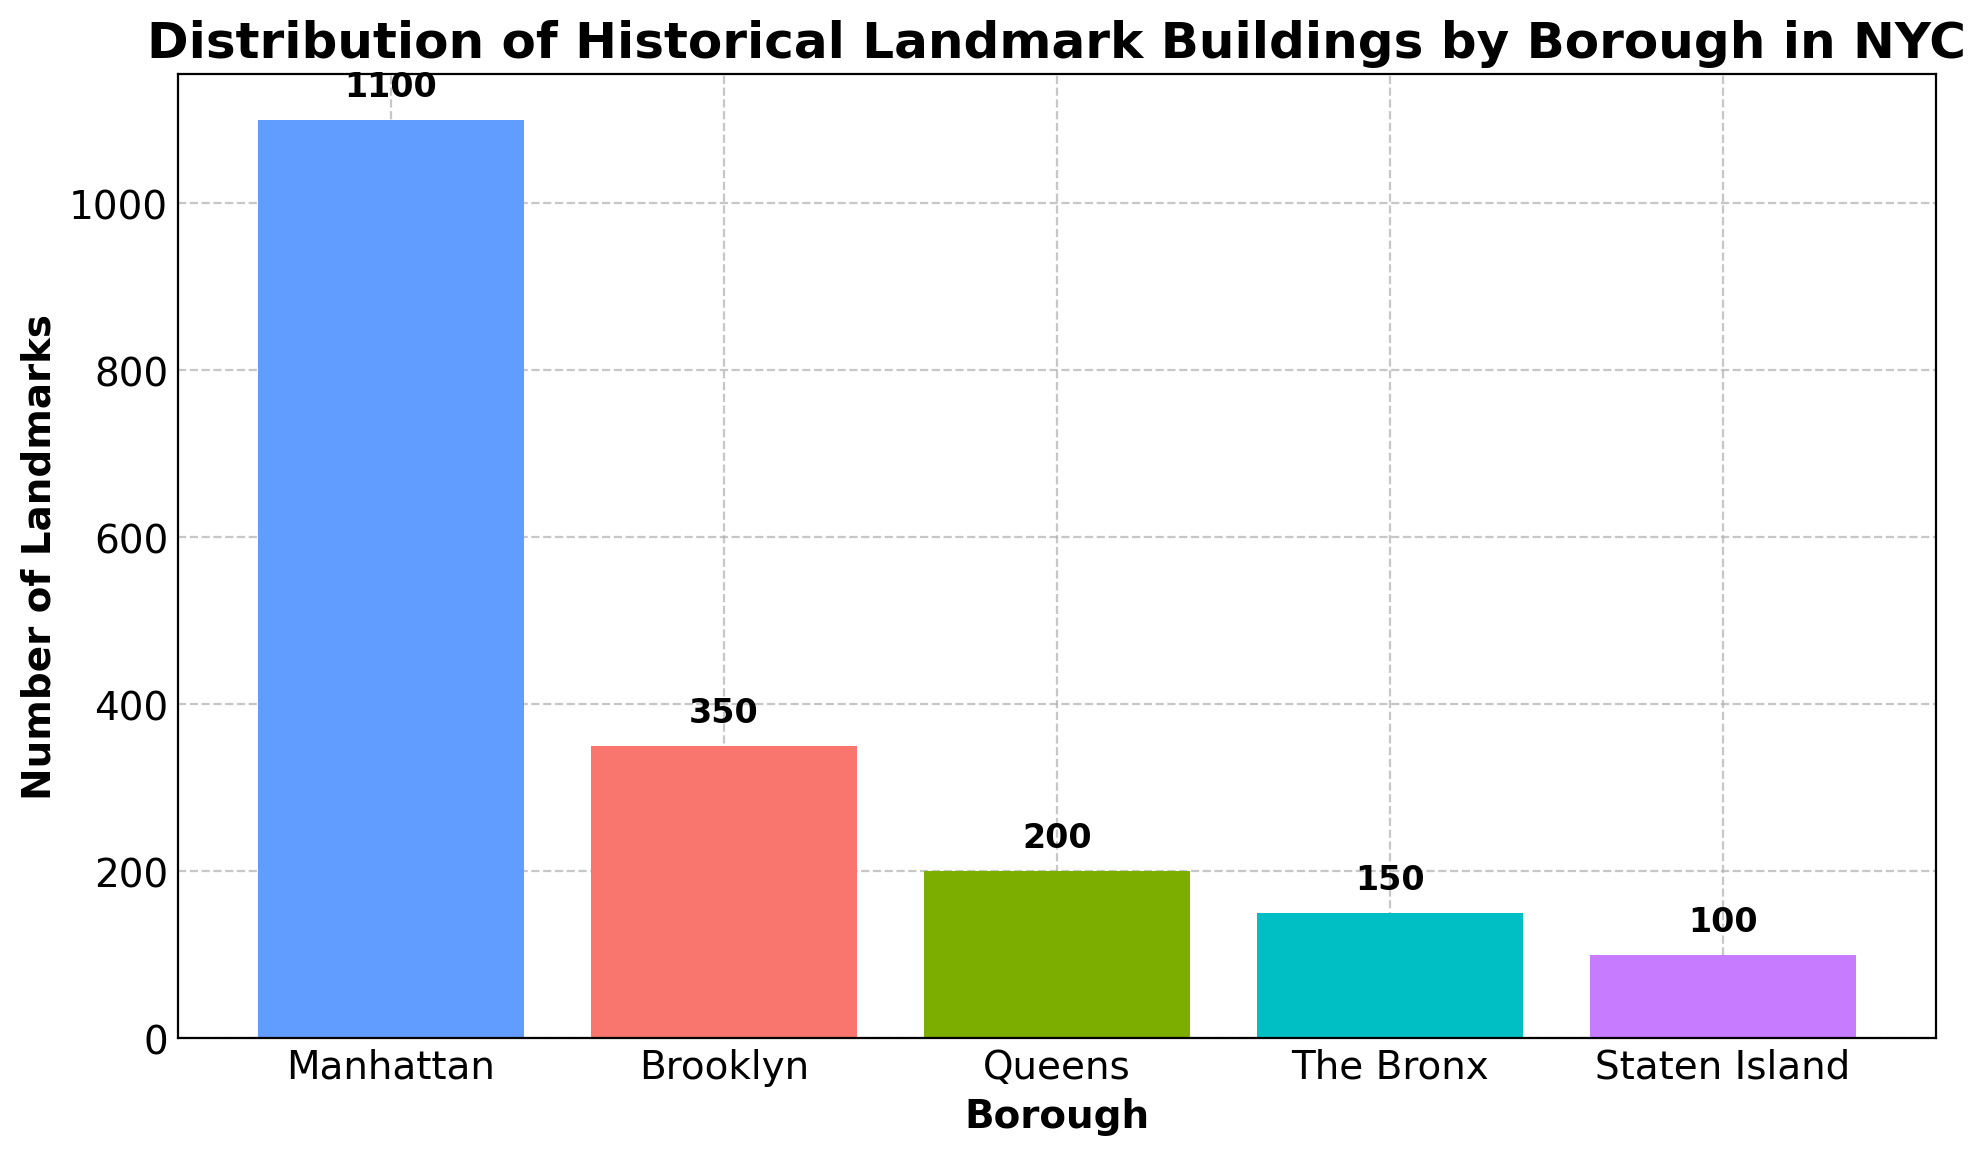What is the total number of historical landmark buildings in all five boroughs? Sum the number of landmarks from each borough: 1100 (Manhattan) + 350 (Brooklyn) + 200 (Queens) + 150 (The Bronx) + 100 (Staten Island) = 1900
Answer: 1900 Which borough has the highest number of historical landmarks? Compare the number of landmarks in each borough: Manhattan (1100) has the highest.
Answer: Manhattan How much greater is the number of landmarks in Manhattan compared to Staten Island? Subtract the number of landmarks in Staten Island from Manhattan: 1100 - 100 = 1000
Answer: 1000 What is the average number of landmarks per borough? Divide the total number of landmarks by the number of boroughs: 1900 / 5 = 380
Answer: 380 Which borough has the second lowest number of historical landmarks? Order the boroughs by the number of landmarks: Staten Island (100) < The Bronx (150) < Queens (200) < Brooklyn (350) < Manhattan (1100); The Bronx is second lowest.
Answer: The Bronx Are there more landmarks in Brooklyn and Queens combined than in Manhattan alone? Sum the landmarks in Brooklyn and Queens: 350 + 200 = 550; Compare with Manhattan: 550 < 1100, so no.
Answer: No By how much is the number of landmarks in Brooklyn less than the total number of landmarks in Queens and The Bronx combined? Calculate the total landmarks in Queens and The Bronx: 200 + 150 = 350; Subtract Brooklyn's landmarks from the combined total: 350 - 350 = 0
Answer: 0 What is the proportional increase in the number of landmarks from Staten Island to Queens? Calculate: (Queens' landmarks - Staten Island's landmarks) / Staten Island's landmarks = (200 - 100) / 100 = 1 or 100%.
Answer: 100% If Manhattan's landmarks were reduced by 10%, how many landmarks would remain? Calculate 10% of Manhattan's landmarks: 1100 * 0.10 = 110; Subtract from the original: 1100 - 110 = 990
Answer: 990 Which two boroughs combined nearly equal the number of landmarks in Manhattan? Summing the landmarks of different pairs: (Brooklyn + Queens = 350 + 200 = 550), (Brooklyn + The Bronx = 350 + 150 = 500), (Brooklyn + Staten Island = 350 + 100 = 450), (Queens + The Bronx = 200 + 150 = 350), (Queens + Staten Island = 200 + 100 = 300), (The Bronx + Staten Island = 150 + 100 = 250); No pair equals 1100, Brooklyn (350) + Queens (200) + The Bronx (150) = 700.
Answer: No two boroughs 